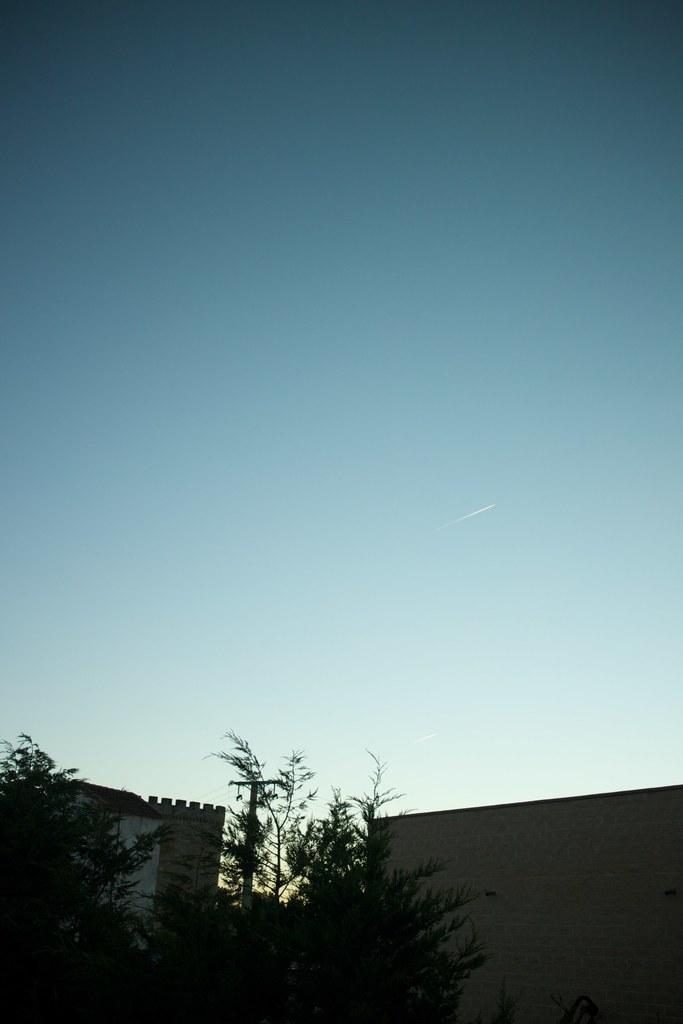Can you describe this image briefly? In this image we can see a tree, walls, current pole and blue sky. 